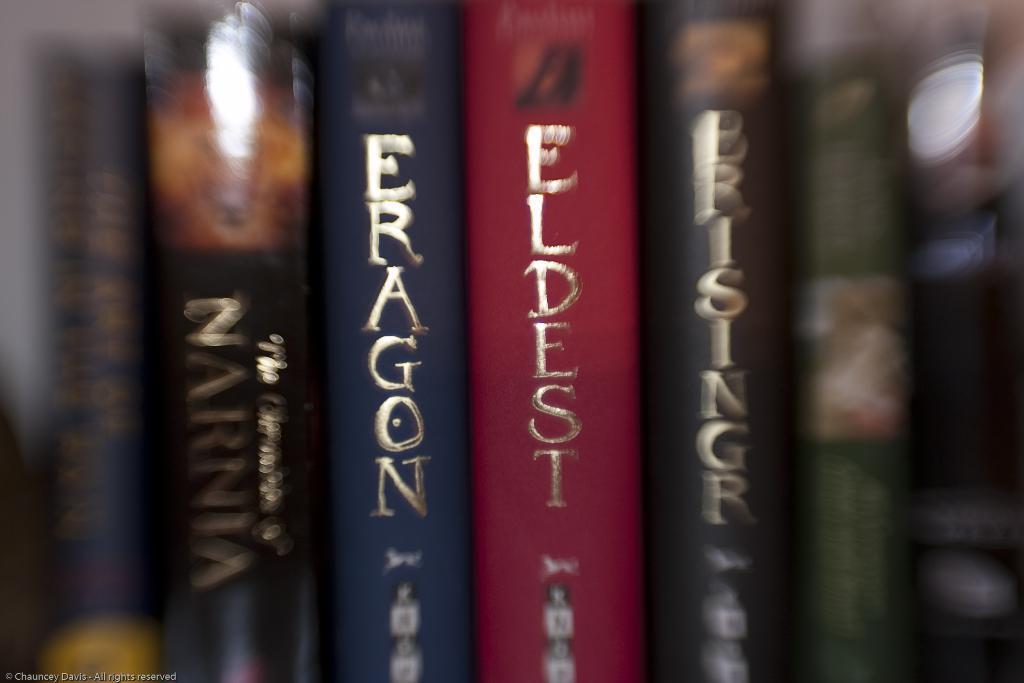In one or two sentences, can you explain what this image depicts? In this image we can see group of books with some text on them. 